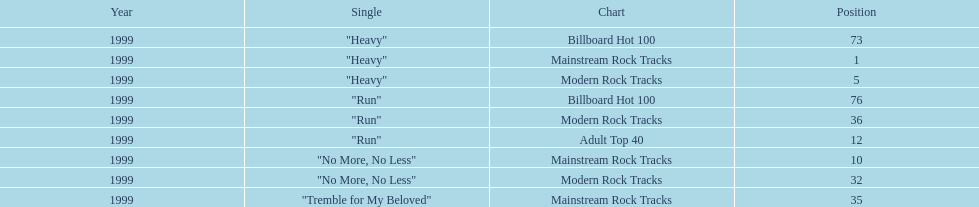What is the number of singles from "dosage" that made it to the modern rock tracks charts? 3. 